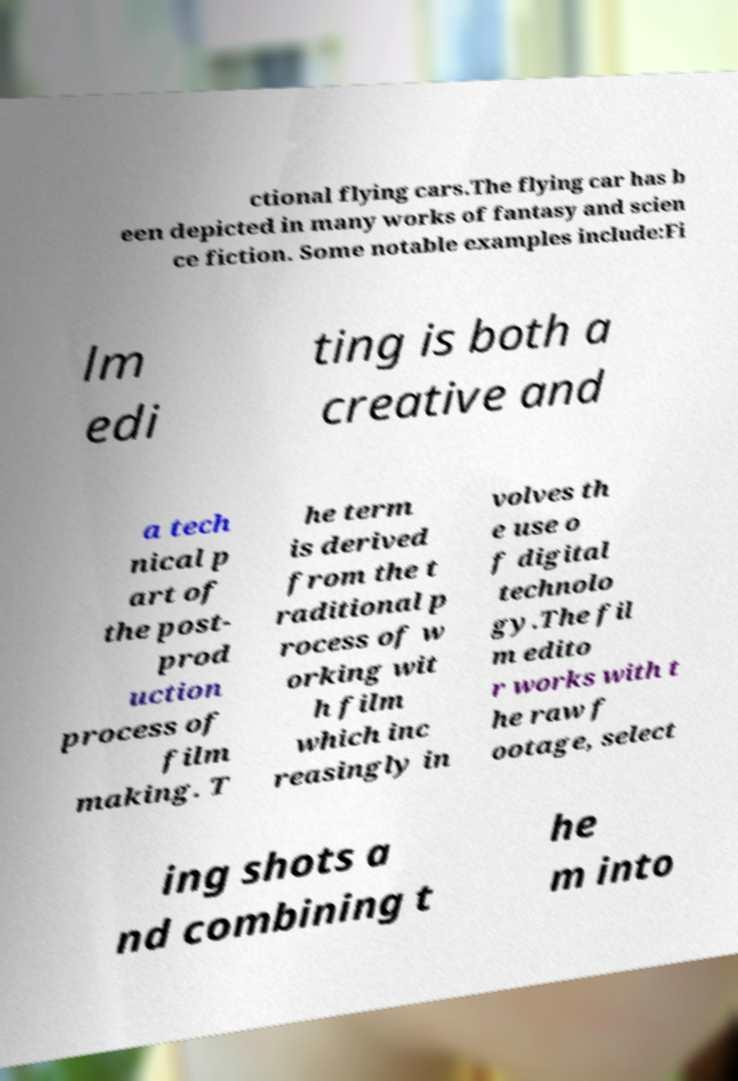Could you assist in decoding the text presented in this image and type it out clearly? ctional flying cars.The flying car has b een depicted in many works of fantasy and scien ce fiction. Some notable examples include:Fi lm edi ting is both a creative and a tech nical p art of the post- prod uction process of film making. T he term is derived from the t raditional p rocess of w orking wit h film which inc reasingly in volves th e use o f digital technolo gy.The fil m edito r works with t he raw f ootage, select ing shots a nd combining t he m into 